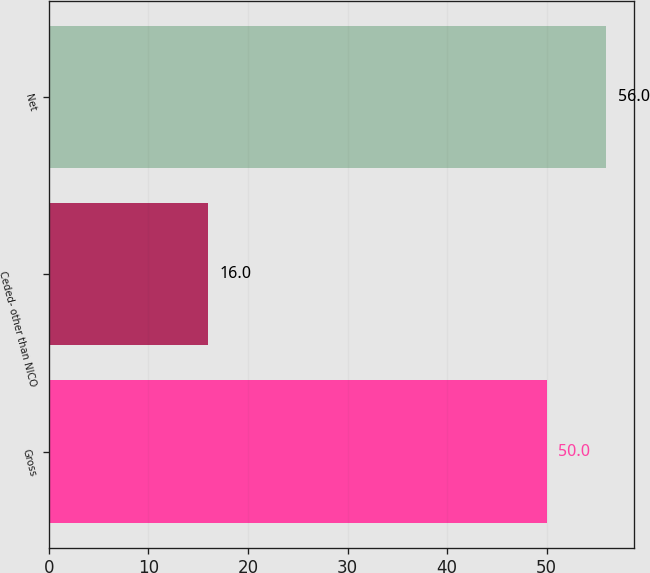Convert chart. <chart><loc_0><loc_0><loc_500><loc_500><bar_chart><fcel>Gross<fcel>Ceded- other than NICO<fcel>Net<nl><fcel>50<fcel>16<fcel>56<nl></chart> 